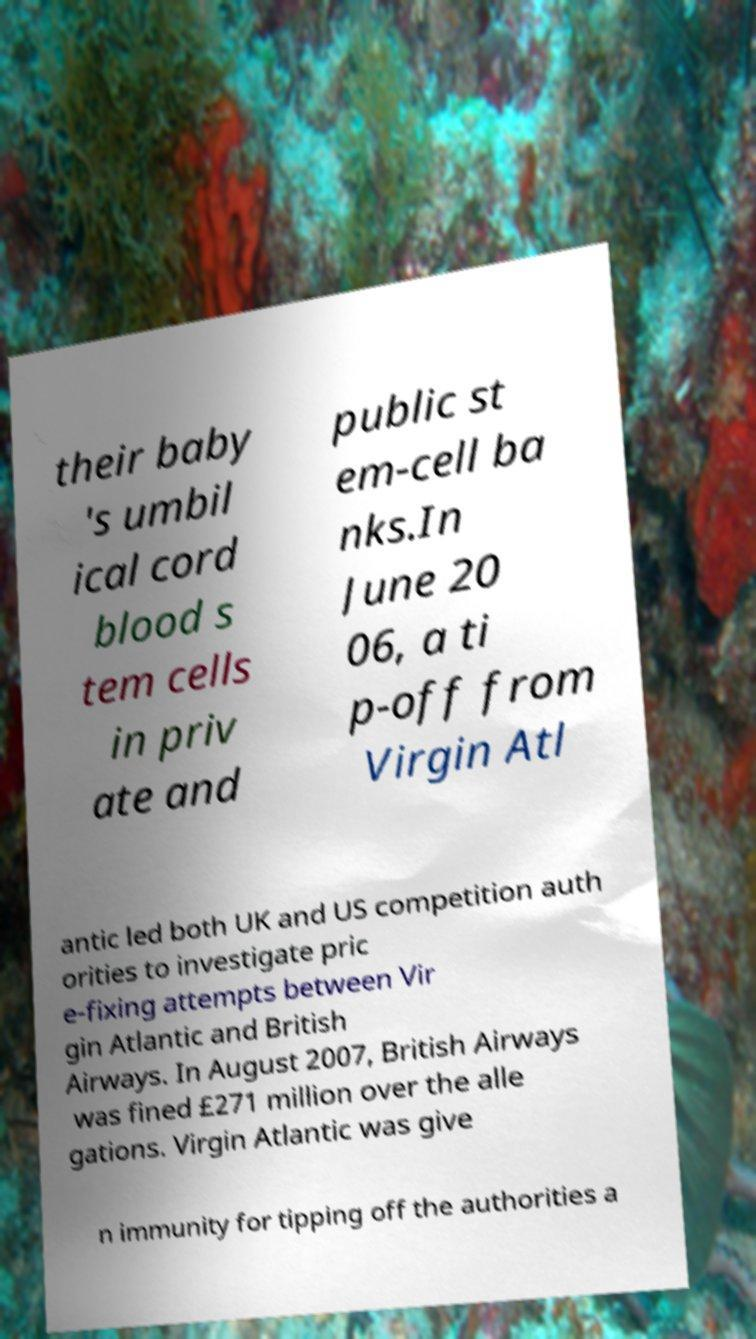Could you extract and type out the text from this image? their baby 's umbil ical cord blood s tem cells in priv ate and public st em-cell ba nks.In June 20 06, a ti p-off from Virgin Atl antic led both UK and US competition auth orities to investigate pric e-fixing attempts between Vir gin Atlantic and British Airways. In August 2007, British Airways was fined £271 million over the alle gations. Virgin Atlantic was give n immunity for tipping off the authorities a 